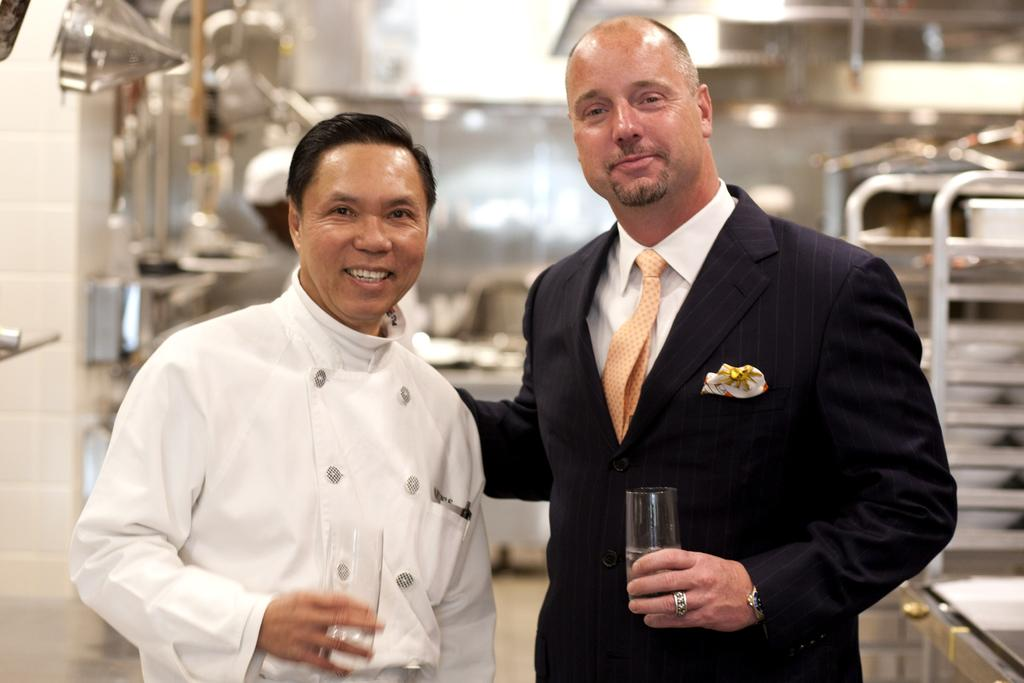How many men are present in the image? There are two men in the middle of the image. What are the men holding in their hands? The men are holding glasses. What can be seen in the background of the image? There is a kitchen in the background of the image. Who else is present in the image besides the two men? There is a chef on the left side of the image. What is the chef holding in his hand? The chef is holding a glass. What type of trail can be seen in the image? There is no trail present in the image; it features two men holding glasses, a kitchen in the background, and a chef holding a glass. 